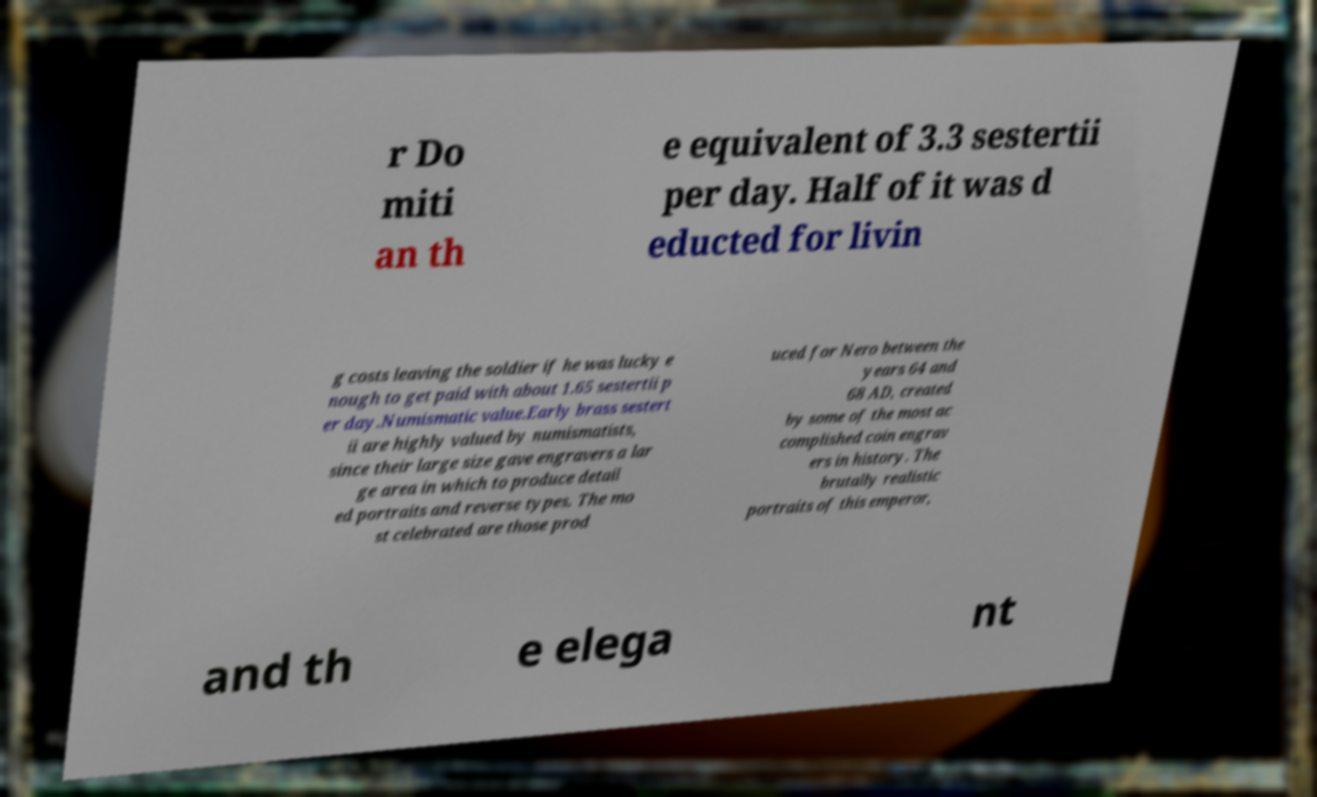Please read and relay the text visible in this image. What does it say? r Do miti an th e equivalent of 3.3 sestertii per day. Half of it was d educted for livin g costs leaving the soldier if he was lucky e nough to get paid with about 1.65 sestertii p er day.Numismatic value.Early brass sestert ii are highly valued by numismatists, since their large size gave engravers a lar ge area in which to produce detail ed portraits and reverse types. The mo st celebrated are those prod uced for Nero between the years 64 and 68 AD, created by some of the most ac complished coin engrav ers in history. The brutally realistic portraits of this emperor, and th e elega nt 